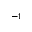Convert formula to latex. <formula><loc_0><loc_0><loc_500><loc_500>^ { - 1 }</formula> 